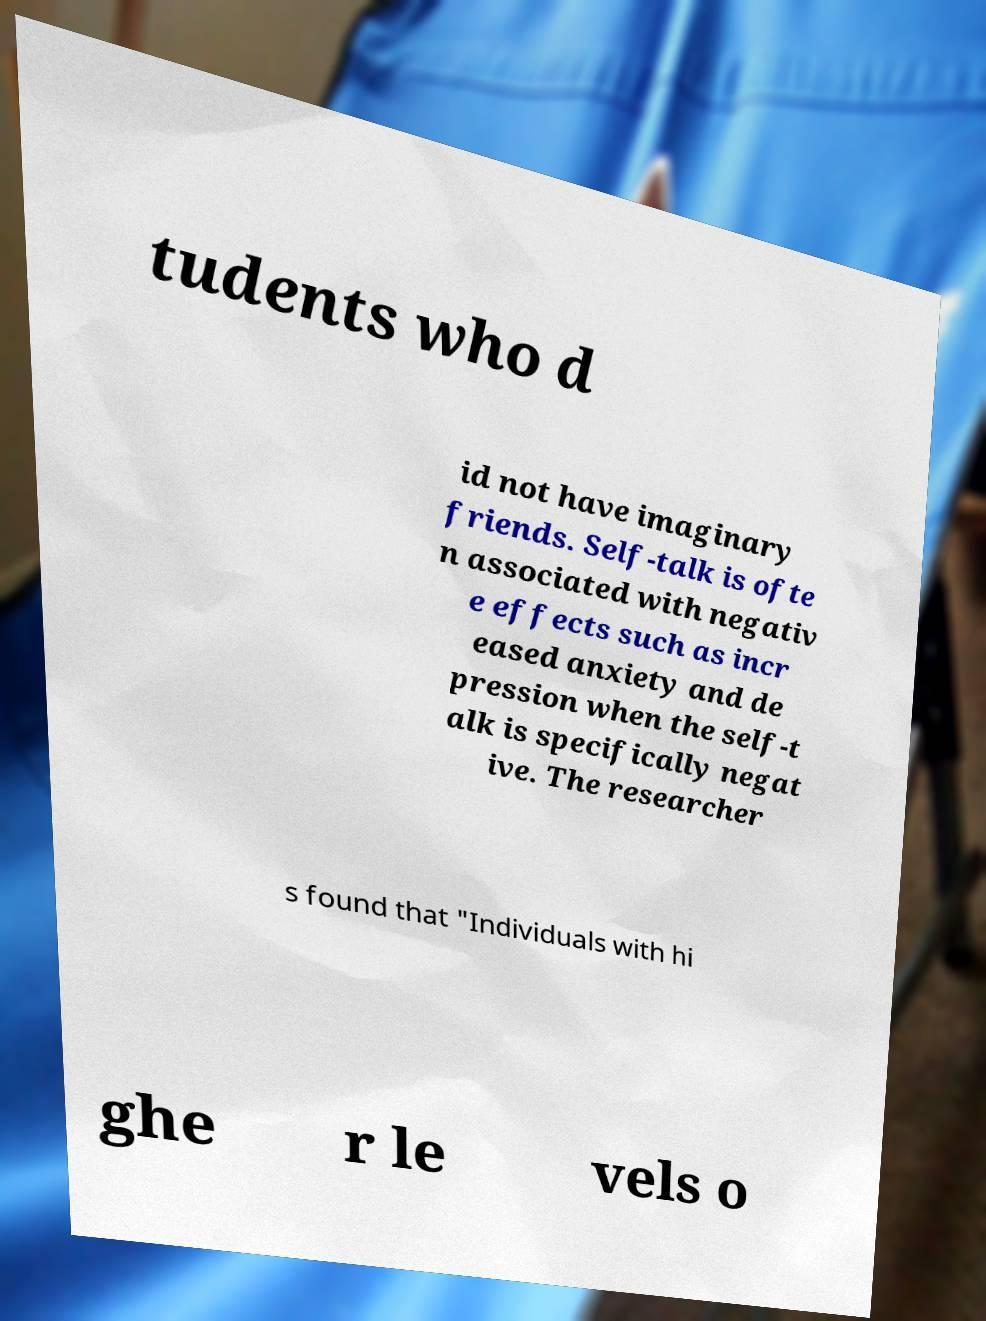Please read and relay the text visible in this image. What does it say? tudents who d id not have imaginary friends. Self-talk is ofte n associated with negativ e effects such as incr eased anxiety and de pression when the self-t alk is specifically negat ive. The researcher s found that "Individuals with hi ghe r le vels o 